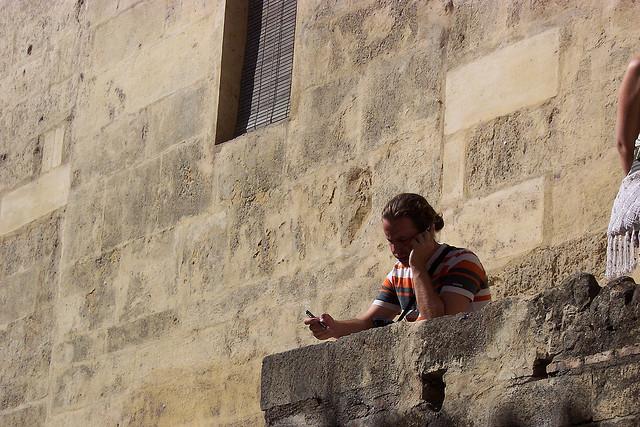What is the building made of?
Give a very brief answer. Stone. Is the person on the phone?
Short answer required. Yes. What hairstyle is the person wearing?
Concise answer only. Bun. 